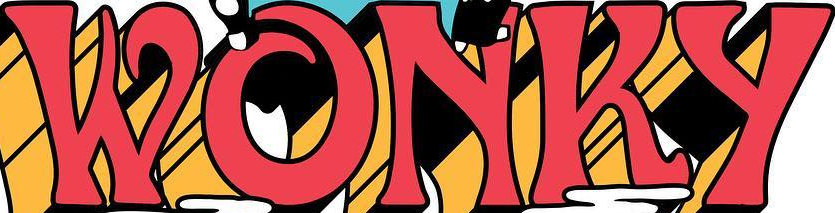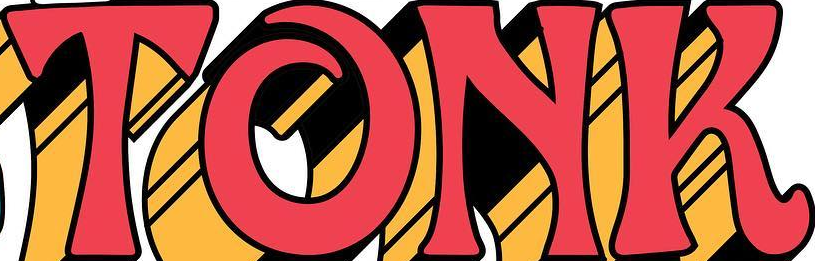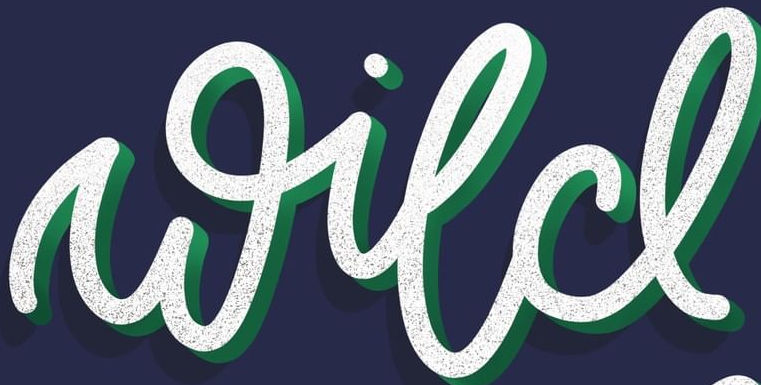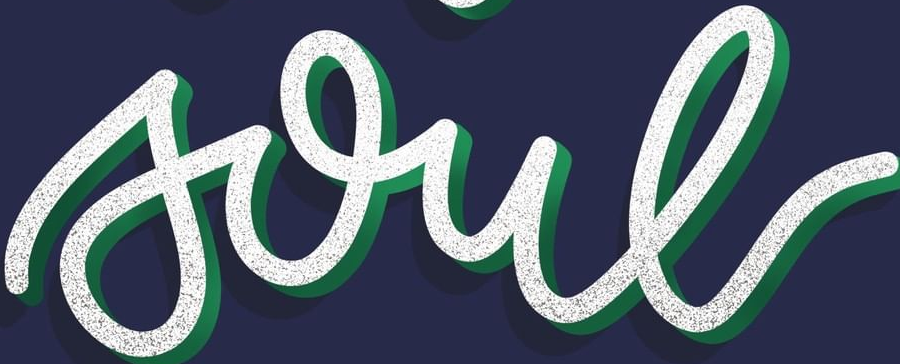Read the text from these images in sequence, separated by a semicolon. WONKY; TONK; wild; soul 